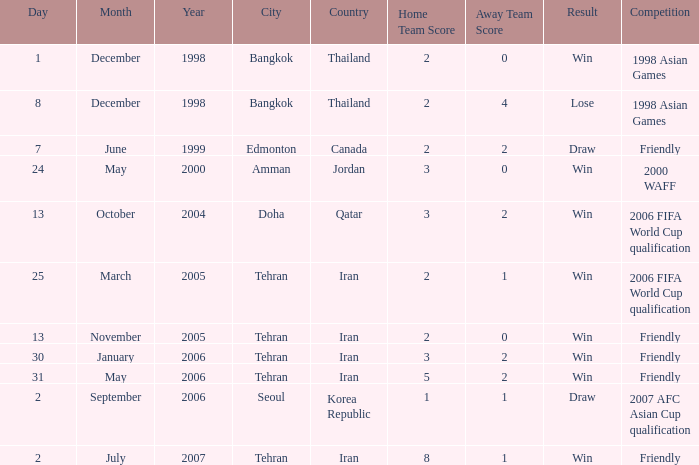What was the competition on 13 November 2005? Friendly. Could you help me parse every detail presented in this table? {'header': ['Day', 'Month', 'Year', 'City', 'Country', 'Home Team Score', 'Away Team Score', 'Result', 'Competition'], 'rows': [['1', 'December', '1998', 'Bangkok', 'Thailand', '2', '0', 'Win', '1998 Asian Games'], ['8', 'December', '1998', 'Bangkok', 'Thailand', '2', '4', 'Lose', '1998 Asian Games'], ['7', 'June', '1999', 'Edmonton', 'Canada', '2', '2', 'Draw', 'Friendly'], ['24', 'May', '2000', 'Amman', 'Jordan', '3', '0', 'Win', '2000 WAFF'], ['13', 'October', '2004', 'Doha', 'Qatar', '3', '2', 'Win', '2006 FIFA World Cup qualification'], ['25', 'March', '2005', 'Tehran', 'Iran', '2', '1', 'Win', '2006 FIFA World Cup qualification'], ['13', 'November', '2005', 'Tehran', 'Iran', '2', '0', 'Win', 'Friendly'], ['30', 'January', '2006', 'Tehran', 'Iran', '3', '2', 'Win', 'Friendly'], ['31', 'May', '2006', 'Tehran', 'Iran', '5', '2', 'Win', 'Friendly'], ['2', 'September', '2006', 'Seoul', 'Korea Republic', '1', '1', 'Draw', '2007 AFC Asian Cup qualification'], ['2', 'July', '2007', 'Tehran', 'Iran', '8', '1', 'Win', 'Friendly']]} 